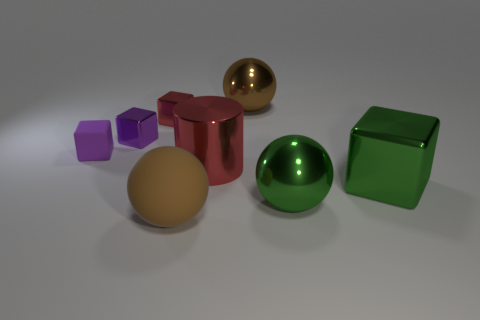Add 2 metal blocks. How many objects exist? 10 Subtract all cylinders. How many objects are left? 7 Subtract 2 purple cubes. How many objects are left? 6 Subtract all big matte balls. Subtract all purple shiny things. How many objects are left? 6 Add 1 spheres. How many spheres are left? 4 Add 1 purple metallic objects. How many purple metallic objects exist? 2 